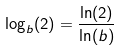Convert formula to latex. <formula><loc_0><loc_0><loc_500><loc_500>\log _ { b } ( 2 ) = \frac { \ln ( 2 ) } { \ln ( b ) }</formula> 